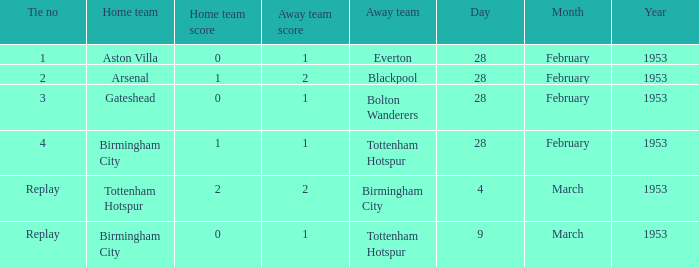What score does the home team aston villa have? 0–1. 